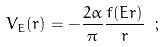Convert formula to latex. <formula><loc_0><loc_0><loc_500><loc_500>V _ { E } ( r ) = - \frac { 2 \alpha } { \pi } \frac { f ( E r ) } { r } \ ;</formula> 